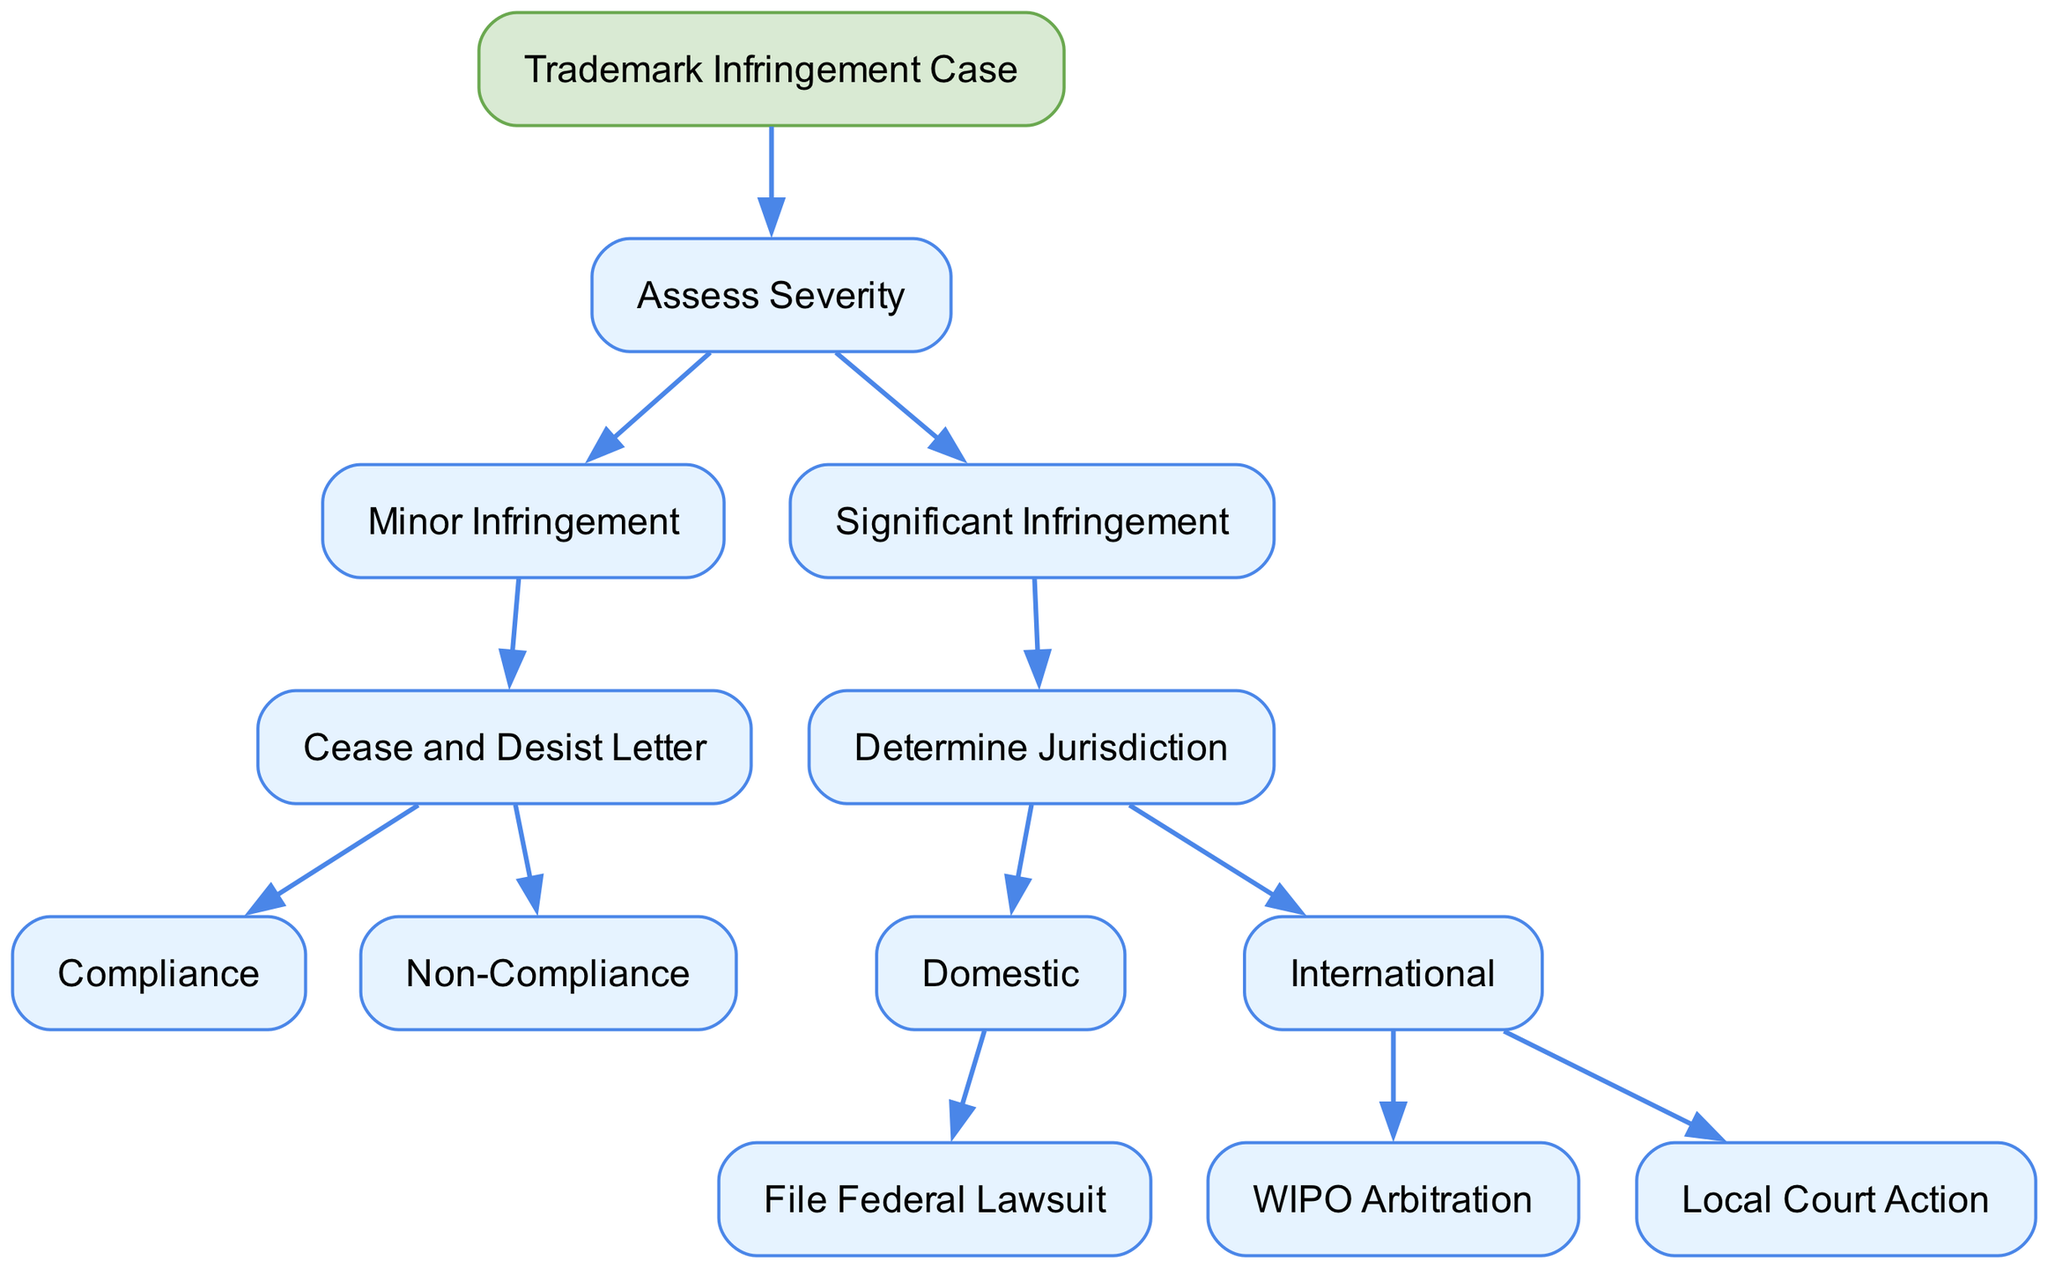What is the root node of the diagram? The root node is the starting point of the decision tree, which is represented as "Trademark Infringement Case". This is explicitly stated at the top of the diagram and serves as the basis for all subsequent decisions.
Answer: Trademark Infringement Case How many options are there after assessing severity? After assessing severity, there are two main options: "Minor Infringement" and "Significant Infringement". This can be counted directly from the branches stemming from the "Assess Severity" node.
Answer: 2 What action is taken for minor infringement? For minor infringement, the action taken is a "Cease and Desist Letter". This is the only option available for the minor infringement pathway in the decision tree.
Answer: Cease and Desist Letter If there is non-compliance after the cease and desist letter, what is the next step? If there is non-compliance following the cease and desist letter, the next step is to "Escalate to Legal Action". This follows directly from the decision path shown for non-compliance.
Answer: Escalate to Legal Action What are the options available for significant infringement regarding jurisdiction? For significant infringement, the options regarding jurisdiction are "Domestic" and "International". These options are presented as branching paths that follow the significant infringement assessment.
Answer: Domestic, International What is the outcome of filing a federal lawsuit in a domestic jurisdiction? The outcome of filing a federal lawsuit in a domestic jurisdiction is to "Seek Injunction and Damages". This is explicitly detailed as the result of choosing the federal lawsuit option under the domestic jurisdiction branch.
Answer: Seek Injunction and Damages What legal options are available for international jurisdiction? The legal options available for international jurisdiction are "WIPO Arbitration" and "Local Court Action". These are the two paths specified under the international jurisdiction option for significant infringement.
Answer: WIPO Arbitration, Local Court Action What outcome is reached through WIPO arbitration? The outcome reached through WIPO arbitration is a "Binding Resolution". This is directly stated as the result of choosing the WIPO arbitration option in the international path.
Answer: Binding Resolution What is the next step after choosing local court action in international jurisdiction? After choosing local court action in international jurisdiction, the next step is "Enforce Judgment Internationally". This is clearly defined as the outcome of the local court action path in the diagram.
Answer: Enforce Judgment Internationally 